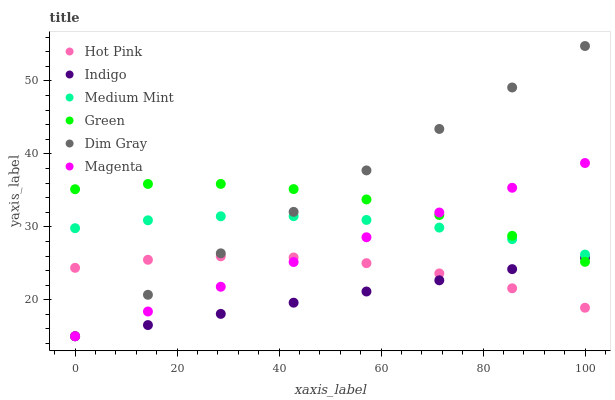Does Indigo have the minimum area under the curve?
Answer yes or no. Yes. Does Dim Gray have the maximum area under the curve?
Answer yes or no. Yes. Does Dim Gray have the minimum area under the curve?
Answer yes or no. No. Does Indigo have the maximum area under the curve?
Answer yes or no. No. Is Magenta the smoothest?
Answer yes or no. Yes. Is Green the roughest?
Answer yes or no. Yes. Is Dim Gray the smoothest?
Answer yes or no. No. Is Dim Gray the roughest?
Answer yes or no. No. Does Dim Gray have the lowest value?
Answer yes or no. Yes. Does Hot Pink have the lowest value?
Answer yes or no. No. Does Dim Gray have the highest value?
Answer yes or no. Yes. Does Indigo have the highest value?
Answer yes or no. No. Is Hot Pink less than Green?
Answer yes or no. Yes. Is Medium Mint greater than Indigo?
Answer yes or no. Yes. Does Green intersect Magenta?
Answer yes or no. Yes. Is Green less than Magenta?
Answer yes or no. No. Is Green greater than Magenta?
Answer yes or no. No. Does Hot Pink intersect Green?
Answer yes or no. No. 